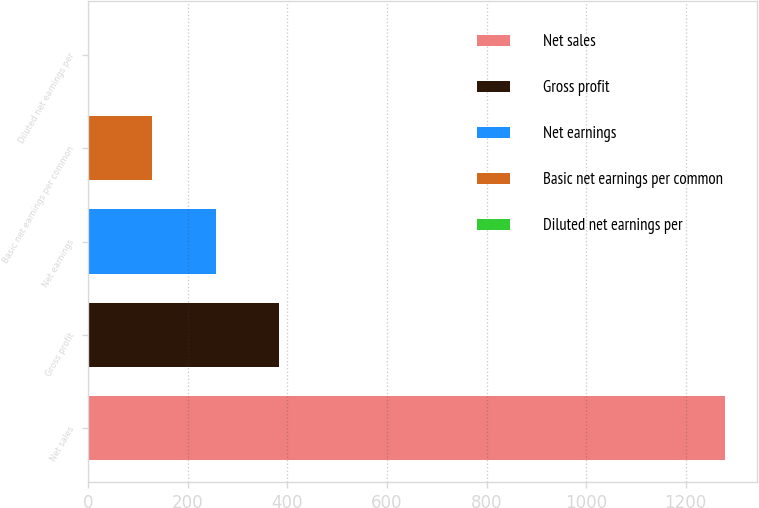Convert chart to OTSL. <chart><loc_0><loc_0><loc_500><loc_500><bar_chart><fcel>Net sales<fcel>Gross profit<fcel>Net earnings<fcel>Basic net earnings per common<fcel>Diluted net earnings per<nl><fcel>1278.8<fcel>383.89<fcel>256.04<fcel>128.19<fcel>0.34<nl></chart> 